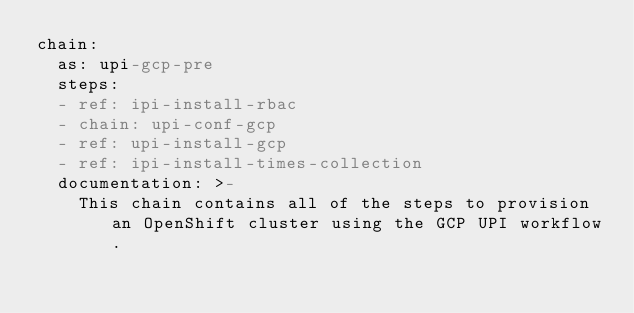Convert code to text. <code><loc_0><loc_0><loc_500><loc_500><_YAML_>chain:
  as: upi-gcp-pre
  steps:
  - ref: ipi-install-rbac
  - chain: upi-conf-gcp
  - ref: upi-install-gcp
  - ref: ipi-install-times-collection
  documentation: >-
    This chain contains all of the steps to provision an OpenShift cluster using the GCP UPI workflow.
</code> 